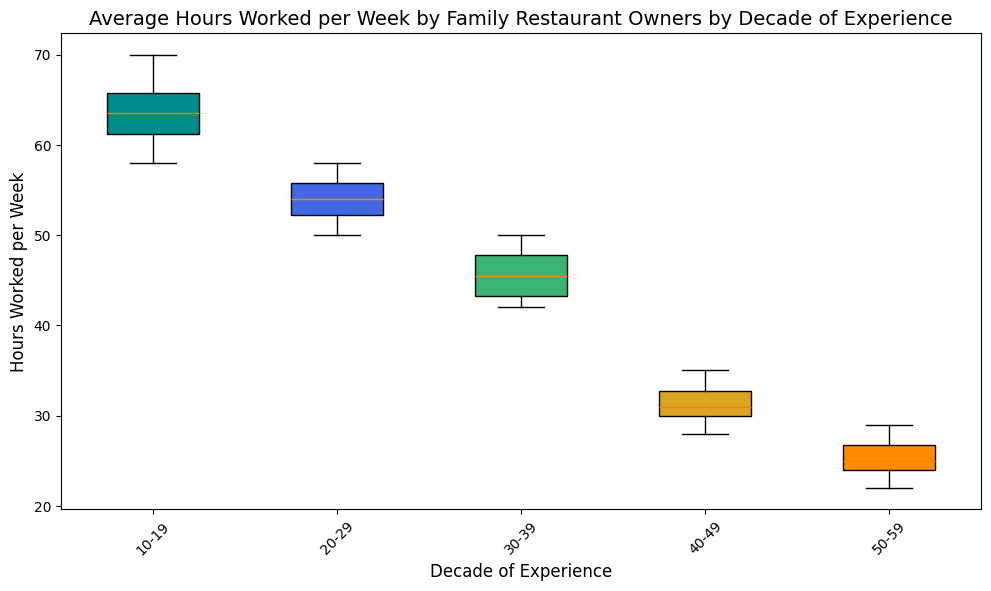Which decade has the highest median number of hours worked per week? The figure shows multiple box plots representing average hours worked per week categorized by the decade of experience. To find the highest median, locate the line within each box plot that represents the median (middle value). The tallest median line belongs to the first decade of experience.
Answer: 1st decade How does the interquartile range (IQR) of hours worked per week change across decades? The IQR is the range between the first quartile (lower edge of the box) and the third quartile (upper edge of the box). Observe the height of each box across the decades. Initially, the boxes appear taller, indicating larger IQRs, and they get smaller with increasing experience, showing that IQR decreases.
Answer: IQR decreases Which decades have the smallest and largest ranges of hours worked per week? The range is determined by the distance between the upper and lower "whiskers" of the box plots. The largest range is observed in the first decade, as its whiskers are the farthest apart, and the smallest range is seen in the fifth decade, where whiskers are the closest.
Answer: 1st and 5th decades What is the overall trend in the median hours worked per week based on decade of experience? To determine the trend, follow the median lines within the boxes from left to right (from least experienced to most experienced). The median lines show a decreasing pattern as the decades progress, indicating that median hours worked per week tend to decrease with more experience.
Answer: Decreasing trend In which decade is the variability in hours worked per week the highest? Variability can be judged by the total spread of the data points, evident from the whiskers and potential outliers. The first decade shows the greatest variability since the whiskers span the widest range along with several outliers.
Answer: 1st decade 